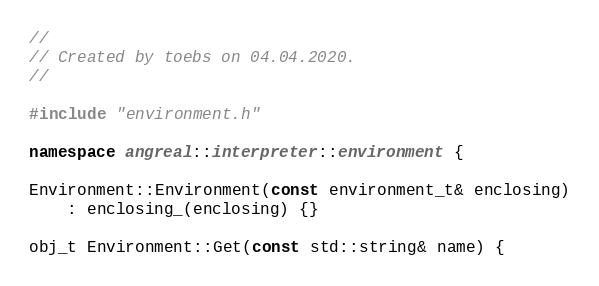Convert code to text. <code><loc_0><loc_0><loc_500><loc_500><_C++_>//
// Created by toebs on 04.04.2020.
//

#include "environment.h"

namespace angreal::interpreter::environment {

Environment::Environment(const environment_t& enclosing)
    : enclosing_(enclosing) {}

obj_t Environment::Get(const std::string& name) {</code> 